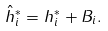Convert formula to latex. <formula><loc_0><loc_0><loc_500><loc_500>\hat { h } ^ { * } _ { i } = h ^ { * } _ { i } + B _ { i } .</formula> 